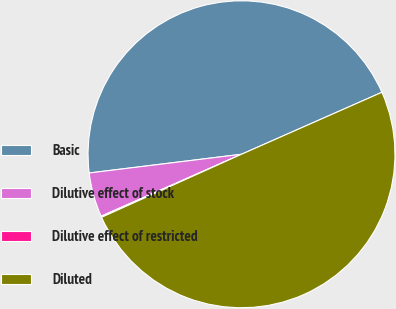Convert chart. <chart><loc_0><loc_0><loc_500><loc_500><pie_chart><fcel>Basic<fcel>Dilutive effect of stock<fcel>Dilutive effect of restricted<fcel>Diluted<nl><fcel>45.33%<fcel>4.67%<fcel>0.12%<fcel>49.88%<nl></chart> 